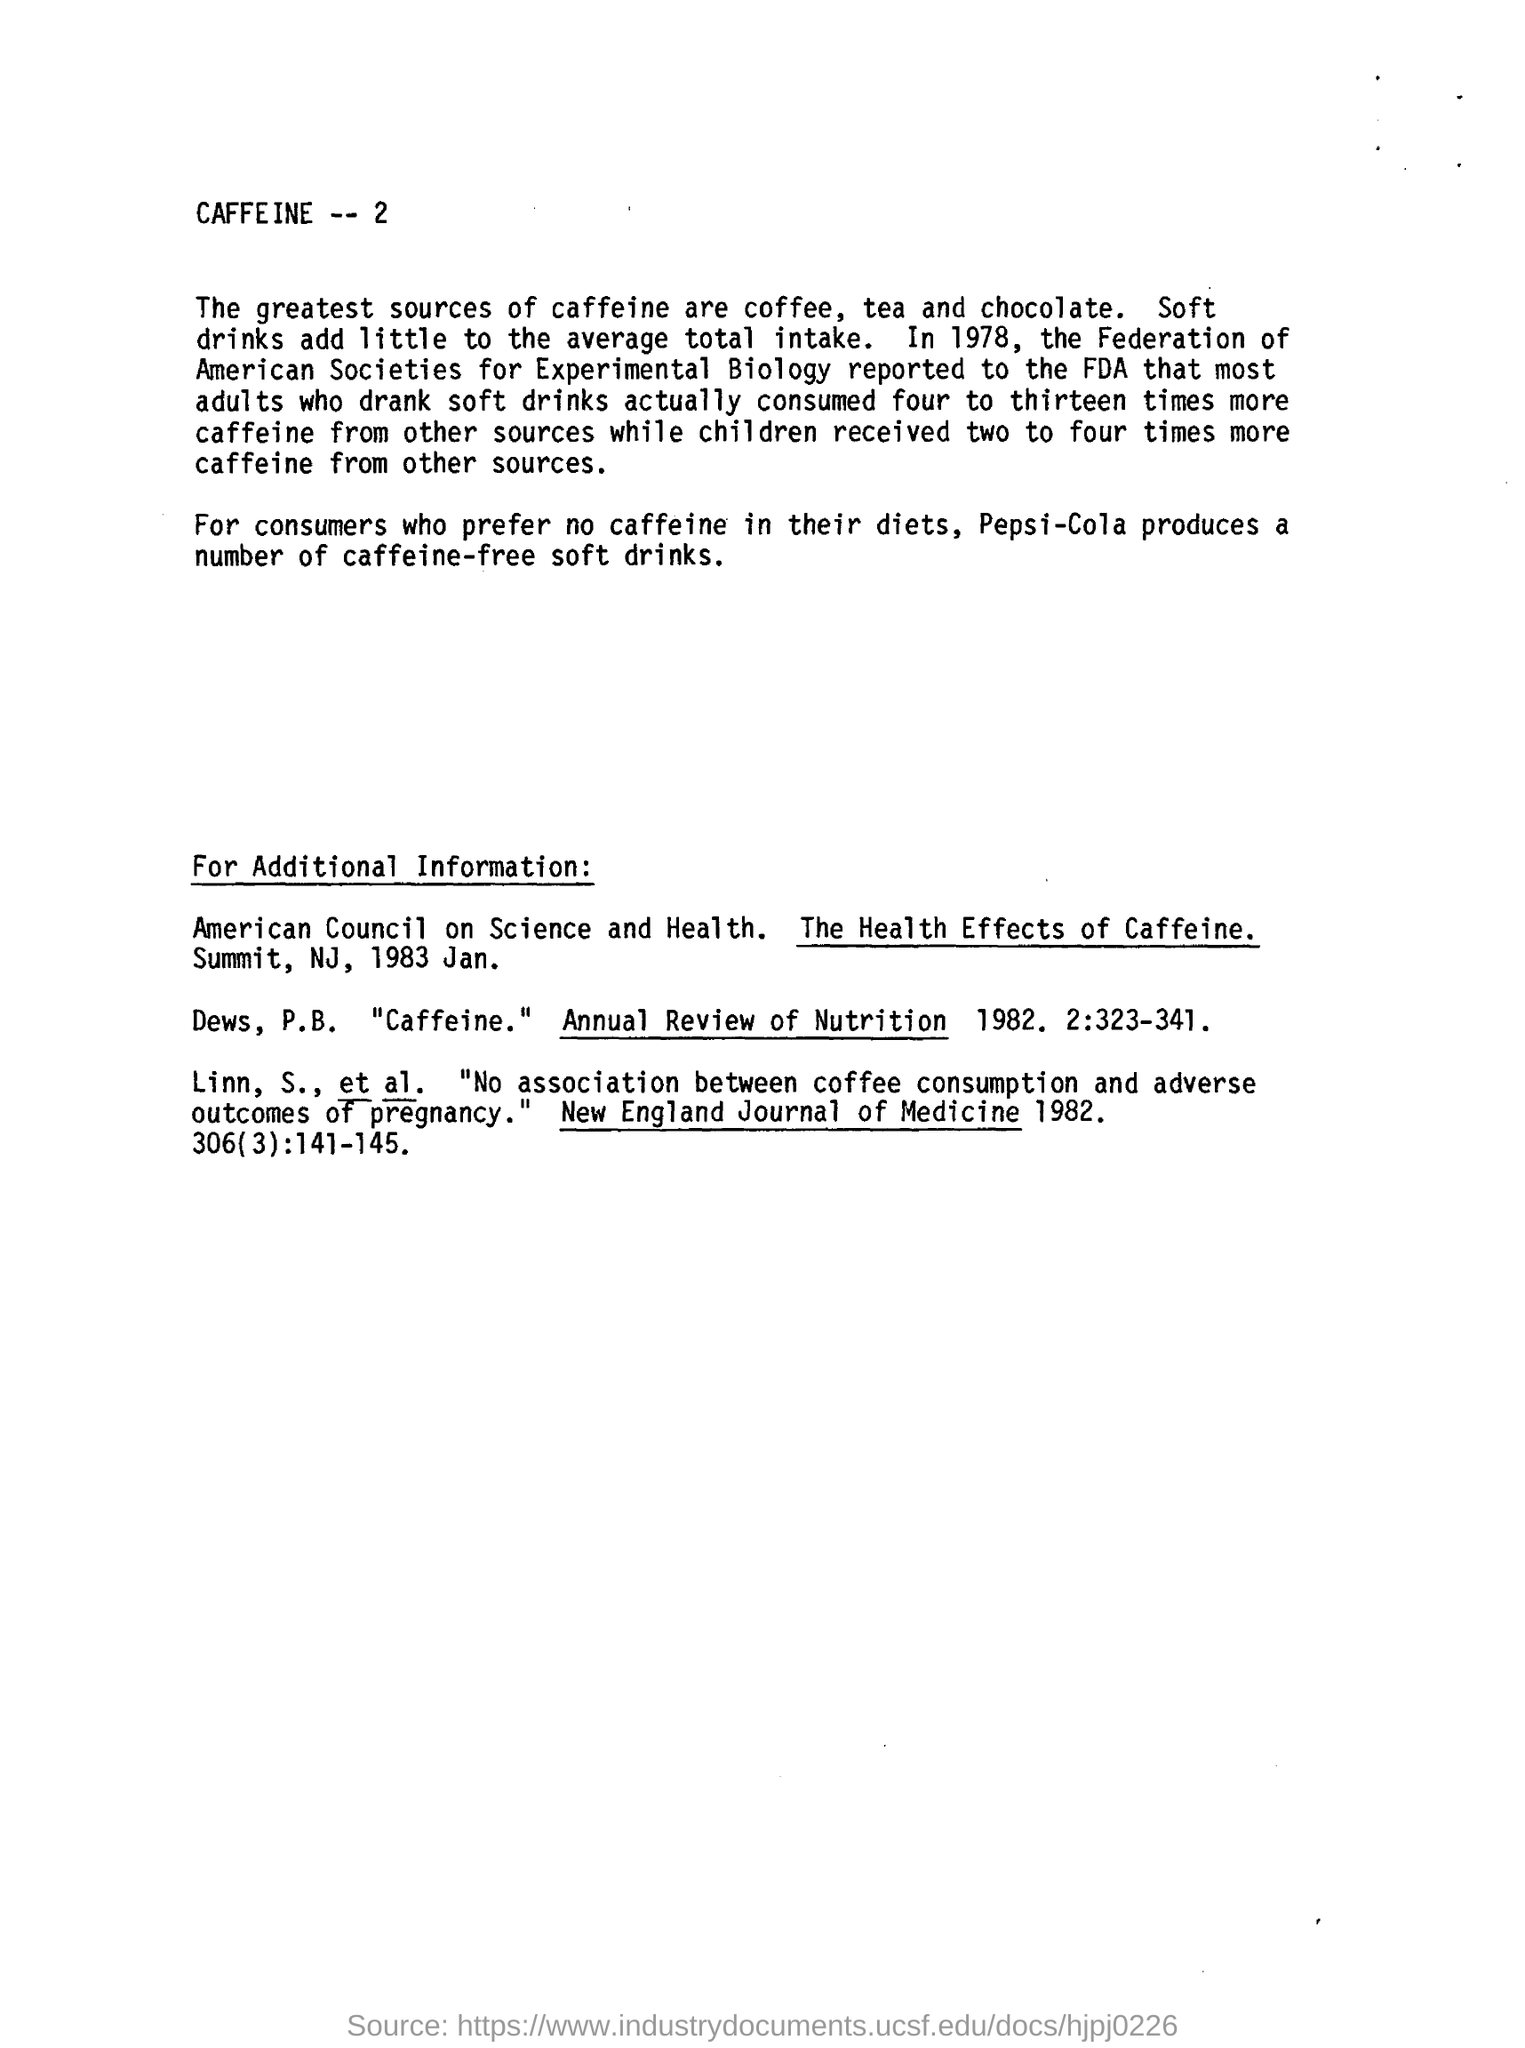what produces a number of caffeine free soft drink for those who prefer no caffeine in their diets?
 Pepsi-Cola 